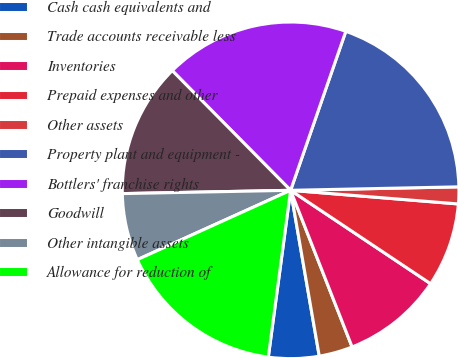Convert chart to OTSL. <chart><loc_0><loc_0><loc_500><loc_500><pie_chart><fcel>Cash cash equivalents and<fcel>Trade accounts receivable less<fcel>Inventories<fcel>Prepaid expenses and other<fcel>Other assets<fcel>Property plant and equipment -<fcel>Bottlers' franchise rights<fcel>Goodwill<fcel>Other intangible assets<fcel>Allowance for reduction of<nl><fcel>4.84%<fcel>3.23%<fcel>9.68%<fcel>8.07%<fcel>1.62%<fcel>19.35%<fcel>17.73%<fcel>12.9%<fcel>6.45%<fcel>16.12%<nl></chart> 